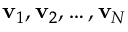Convert formula to latex. <formula><loc_0><loc_0><loc_500><loc_500>v _ { 1 } , v _ { 2 } , \dots , v _ { N }</formula> 